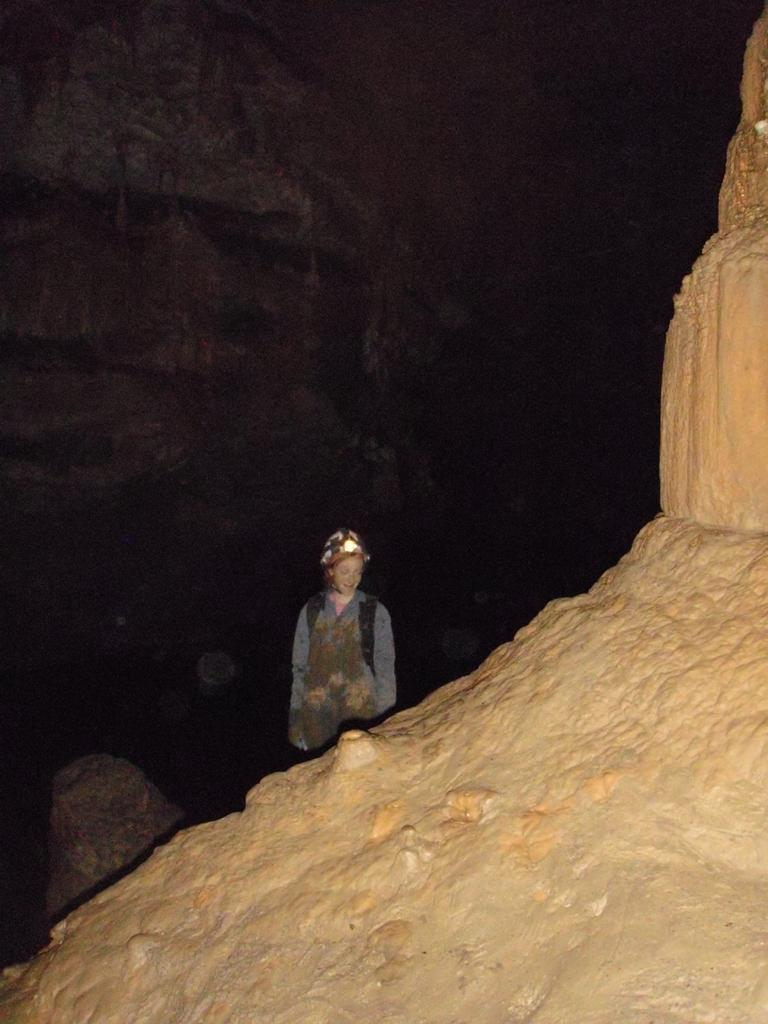What is the main object in the image? There is a rock in the image. Who or what else can be seen in the image? There is a person wearing a helmet in the image. What is the person doing in the image? The person is standing. Are there any other rocks visible in the image? Yes, there is another rock visible in the background of the image. How would you describe the overall appearance of the image? The background appears to be dark. What verse is the person reading from the toy in the image? There is no toy or reading material present in the image. 